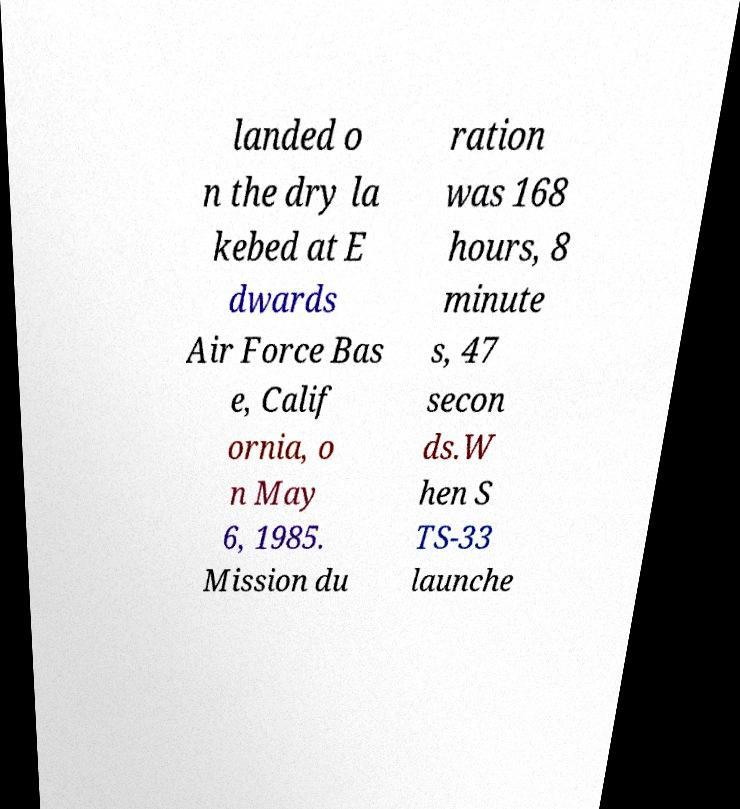For documentation purposes, I need the text within this image transcribed. Could you provide that? landed o n the dry la kebed at E dwards Air Force Bas e, Calif ornia, o n May 6, 1985. Mission du ration was 168 hours, 8 minute s, 47 secon ds.W hen S TS-33 launche 